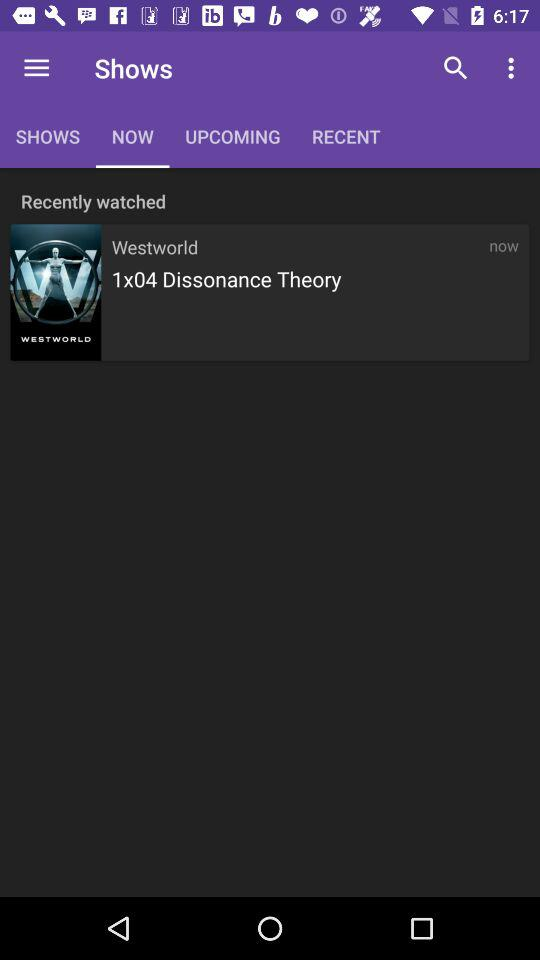What is the name of the show on the recently watched list? The recently watched show is "Westworld". 